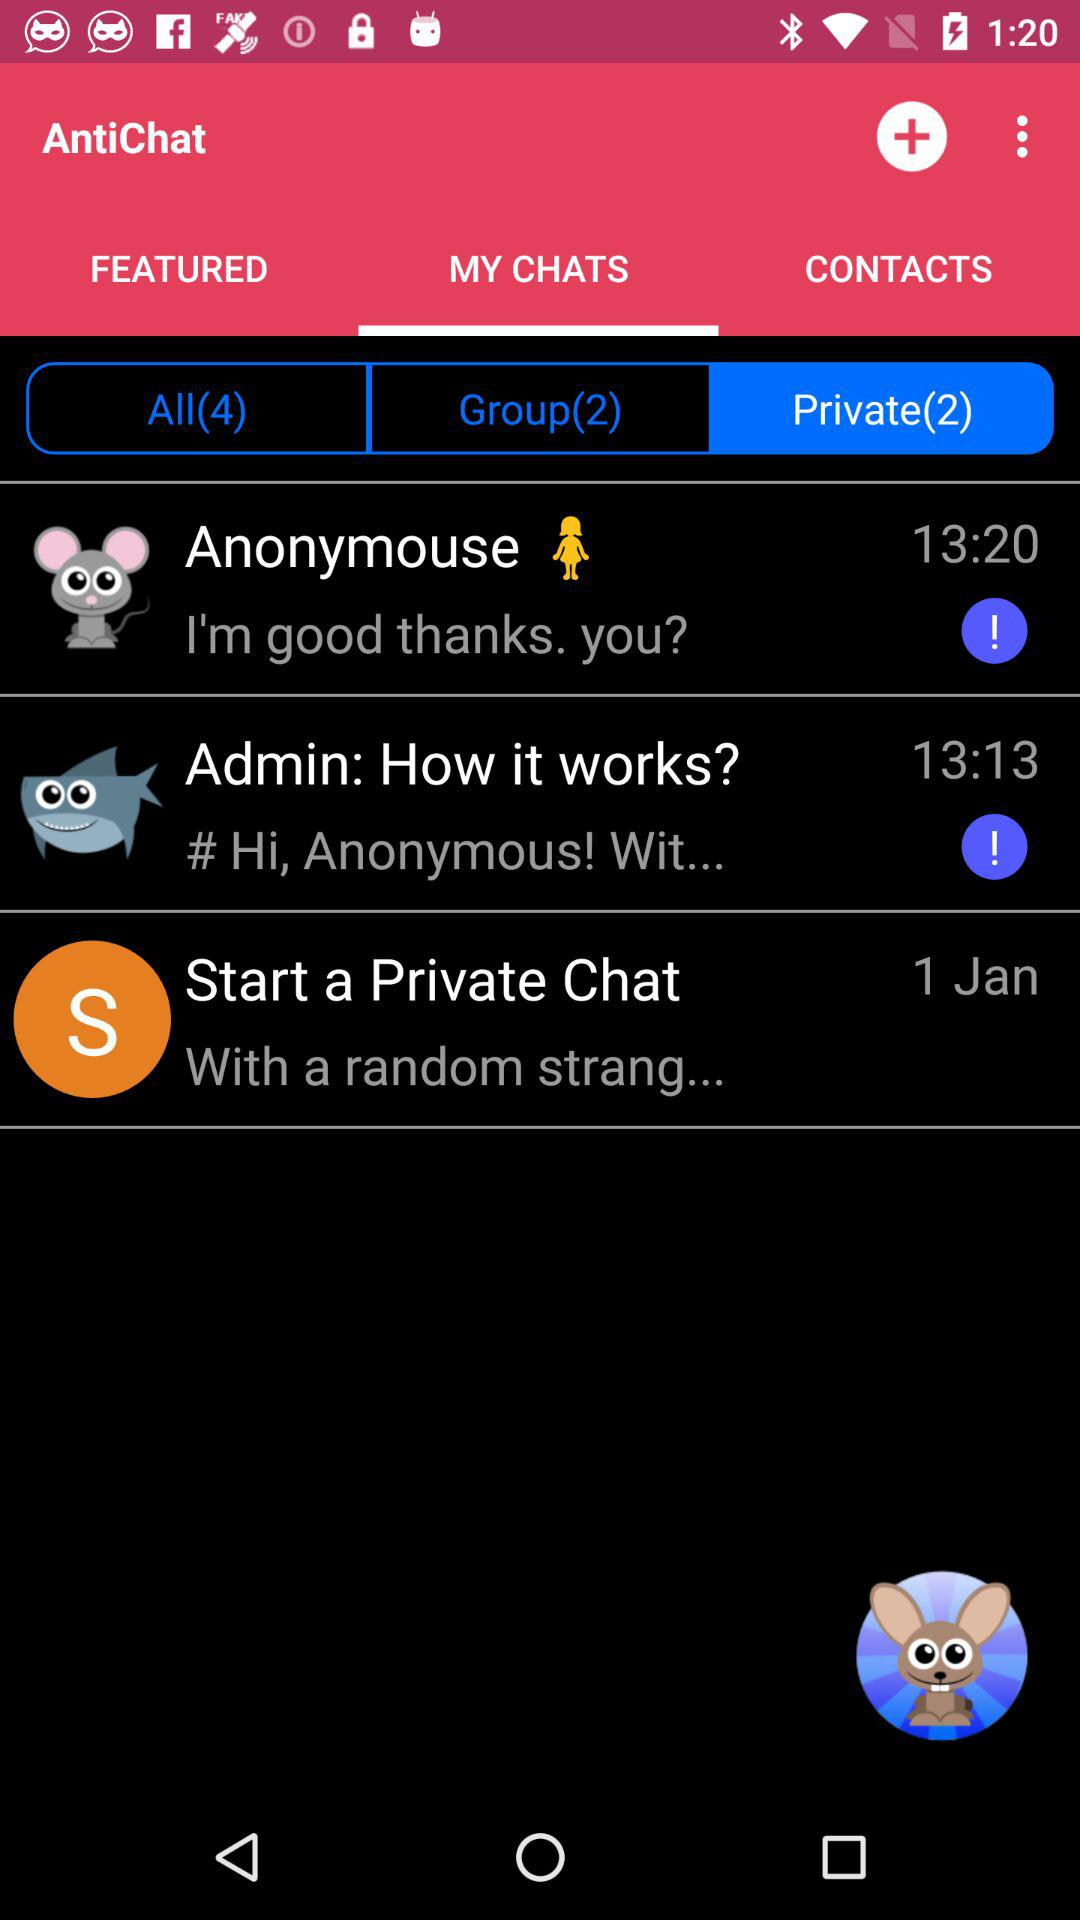How many private chats do you have?
Answer the question using a single word or phrase. 2 